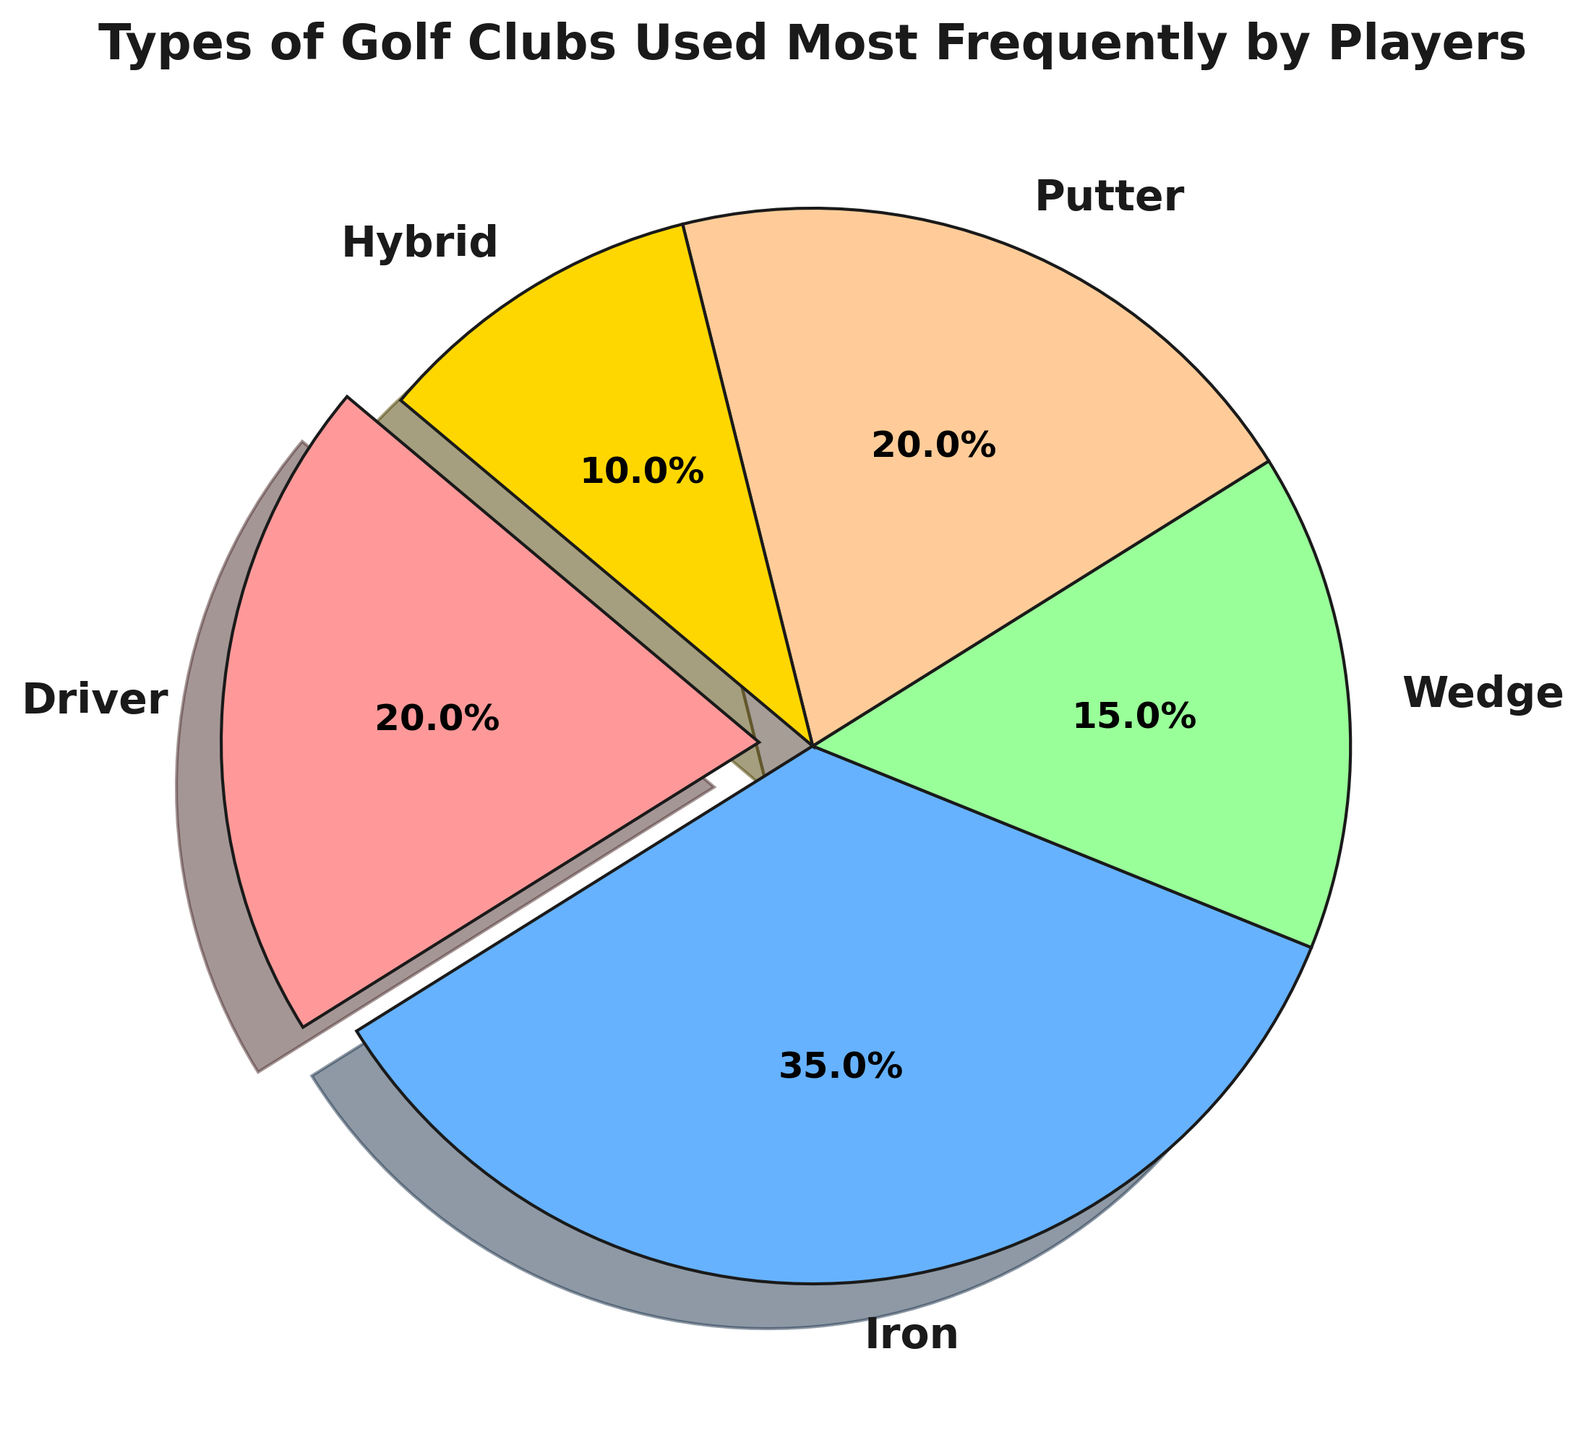What percentage of players use irons frequently? According to the pie chart, 35% of players use irons frequently.
Answer: 35% Which type of golf club is used more frequently: drivers or wedges? Drivers are used by 20% of players, while wedges are used by 15%. Therefore, drivers are used more frequently than wedges.
Answer: Drivers Is the usage frequency of putters equal to the usage frequency of drivers? The pie chart shows that both putters and drivers are used by 20% of players, so their usage frequency is equal.
Answer: Yes What is the total percentage of players who use hybrids and wedges? According to the pie chart, hybrids are used by 10% and wedges by 15% of players. Therefore, the total percentage is 10% + 15% = 25%.
Answer: 25% Which type of golf club has the least frequent usage among players? The pie chart shows that hybrids have the lowest frequency of usage at 10%.
Answer: Hybrid Are the combined usage percentages of drivers and putters greater than the usage of irons? The combined usage of drivers (20%) and putters (20%) is 40%. Since irons are used by 35% of players, 40% is greater than 35%.
Answer: Yes Which type of golf club has the highest usage frequency and by how much does it exceed the lowest frequency type? Irons have the highest usage frequency at 35%, while hybrids have the lowest at 10%. The difference is 35% - 10% = 25%.
Answer: Irons; 25% What is the average usage percentage of all golf clubs shown in the pie chart? To find the average, sum all the usage percentages (20% + 35% + 15% + 20% + 10%) = 100% and divide by the number of categories (5). The average is 100% / 5 = 20%.
Answer: 20% Which segment of the pie chart is highlighted or exploded? The pie chart shows that the driver's segment is exploded or highlighted.
Answer: Driver 